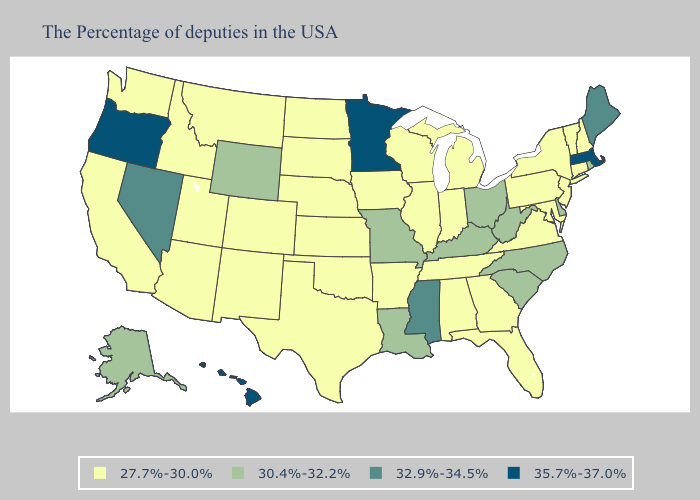What is the lowest value in the USA?
Quick response, please. 27.7%-30.0%. Among the states that border Missouri , does Iowa have the highest value?
Keep it brief. No. What is the lowest value in the South?
Concise answer only. 27.7%-30.0%. What is the highest value in states that border Wyoming?
Keep it brief. 27.7%-30.0%. Name the states that have a value in the range 30.4%-32.2%?
Quick response, please. Rhode Island, Delaware, North Carolina, South Carolina, West Virginia, Ohio, Kentucky, Louisiana, Missouri, Wyoming, Alaska. Does Hawaii have the same value as Oregon?
Quick response, please. Yes. What is the value of New Hampshire?
Write a very short answer. 27.7%-30.0%. What is the value of Rhode Island?
Short answer required. 30.4%-32.2%. Does Minnesota have the highest value in the USA?
Quick response, please. Yes. Which states have the highest value in the USA?
Concise answer only. Massachusetts, Minnesota, Oregon, Hawaii. Name the states that have a value in the range 27.7%-30.0%?
Write a very short answer. New Hampshire, Vermont, Connecticut, New York, New Jersey, Maryland, Pennsylvania, Virginia, Florida, Georgia, Michigan, Indiana, Alabama, Tennessee, Wisconsin, Illinois, Arkansas, Iowa, Kansas, Nebraska, Oklahoma, Texas, South Dakota, North Dakota, Colorado, New Mexico, Utah, Montana, Arizona, Idaho, California, Washington. Among the states that border Kentucky , which have the highest value?
Answer briefly. West Virginia, Ohio, Missouri. Name the states that have a value in the range 27.7%-30.0%?
Keep it brief. New Hampshire, Vermont, Connecticut, New York, New Jersey, Maryland, Pennsylvania, Virginia, Florida, Georgia, Michigan, Indiana, Alabama, Tennessee, Wisconsin, Illinois, Arkansas, Iowa, Kansas, Nebraska, Oklahoma, Texas, South Dakota, North Dakota, Colorado, New Mexico, Utah, Montana, Arizona, Idaho, California, Washington. Which states hav the highest value in the West?
Be succinct. Oregon, Hawaii. Does New Hampshire have the highest value in the Northeast?
Give a very brief answer. No. 